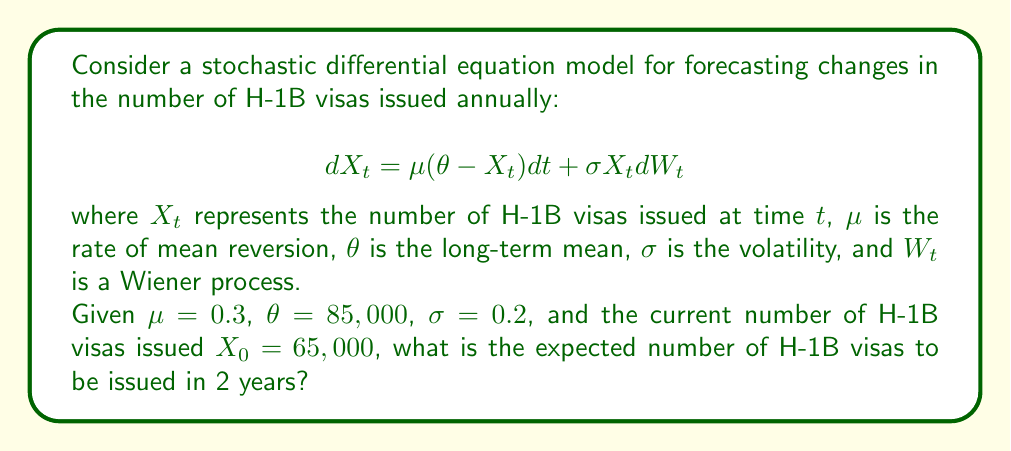What is the answer to this math problem? To solve this problem, we need to use the properties of the Ornstein-Uhlenbeck process, which is described by the given stochastic differential equation.

Step 1: Identify the formula for the expected value of $X_t$:
$$E[X_t] = \theta + (X_0 - \theta)e^{-\mu t}$$

Step 2: Substitute the given values:
$\theta = 85,000$
$X_0 = 65,000$
$\mu = 0.3$
$t = 2$ (years)

Step 3: Calculate the expected value:
$$\begin{align}
E[X_2] &= 85,000 + (65,000 - 85,000)e^{-0.3 \cdot 2} \\
&= 85,000 - 20,000e^{-0.6} \\
&= 85,000 - 20,000 \cdot 0.5488 \\
&= 85,000 - 10,976 \\
&= 74,024
\end{align}$$

Step 4: Round to the nearest whole number, as we're dealing with visa counts:
$E[X_2] \approx 74,024$ (rounded)

Therefore, the expected number of H-1B visas to be issued in 2 years is approximately 74,024.
Answer: 74,024 visas 